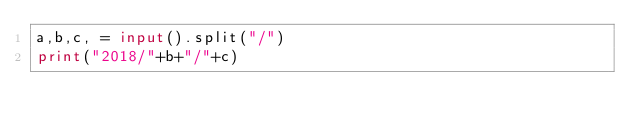<code> <loc_0><loc_0><loc_500><loc_500><_Python_>a,b,c, = input().split("/")
print("2018/"+b+"/"+c)</code> 